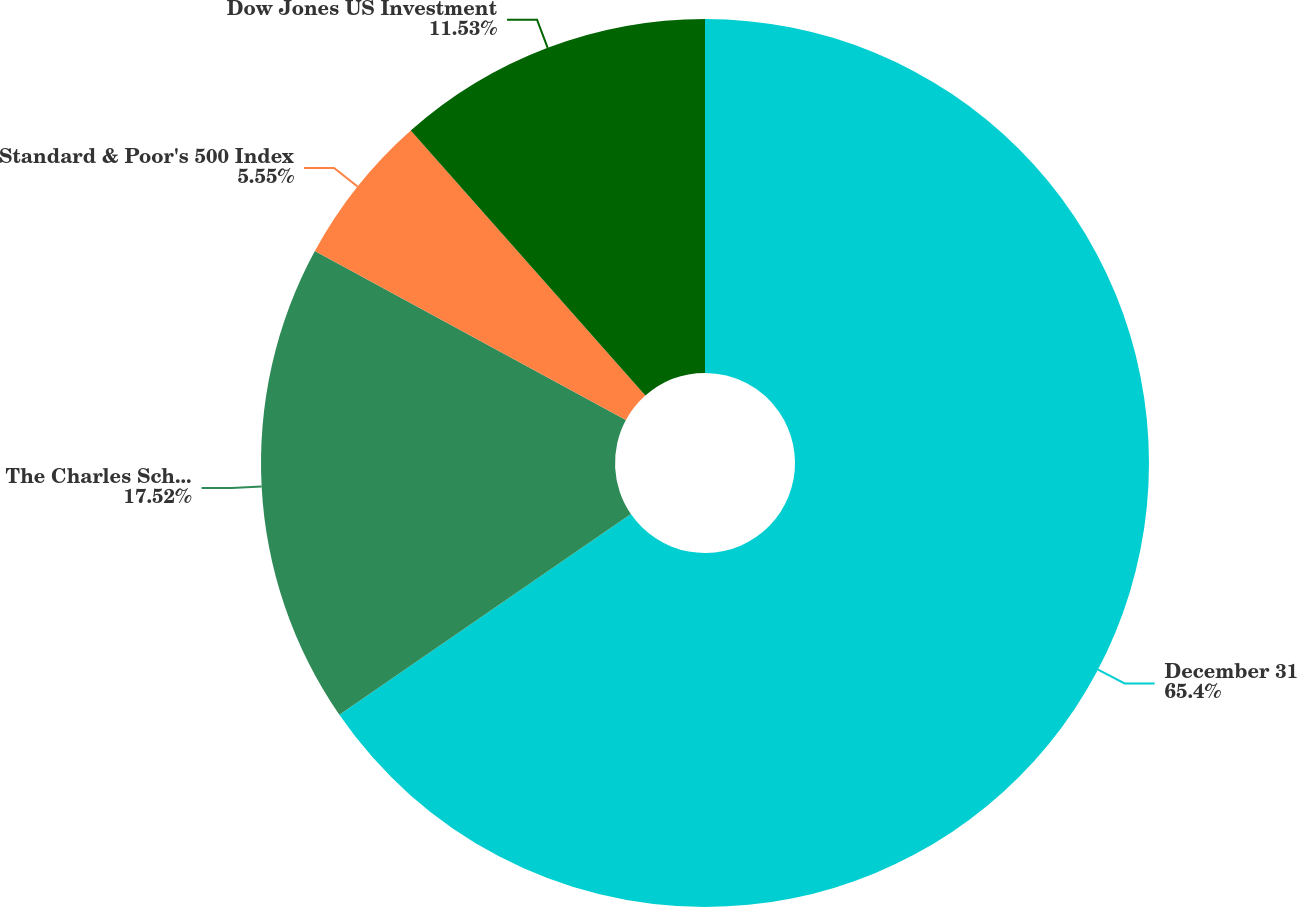Convert chart to OTSL. <chart><loc_0><loc_0><loc_500><loc_500><pie_chart><fcel>December 31<fcel>The Charles Schwab Corporation<fcel>Standard & Poor's 500 Index<fcel>Dow Jones US Investment<nl><fcel>65.4%<fcel>17.52%<fcel>5.55%<fcel>11.53%<nl></chart> 